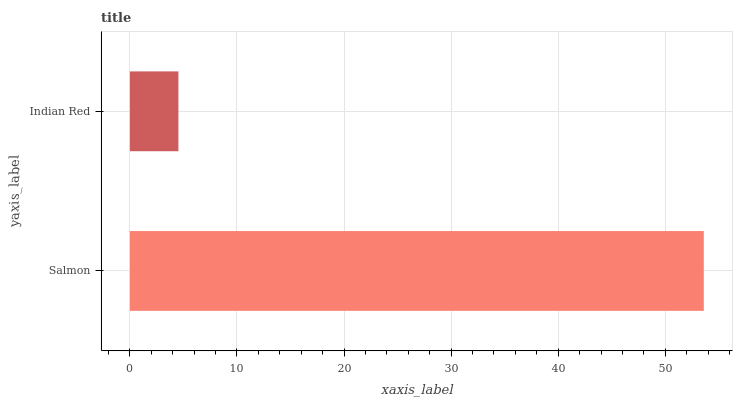Is Indian Red the minimum?
Answer yes or no. Yes. Is Salmon the maximum?
Answer yes or no. Yes. Is Indian Red the maximum?
Answer yes or no. No. Is Salmon greater than Indian Red?
Answer yes or no. Yes. Is Indian Red less than Salmon?
Answer yes or no. Yes. Is Indian Red greater than Salmon?
Answer yes or no. No. Is Salmon less than Indian Red?
Answer yes or no. No. Is Salmon the high median?
Answer yes or no. Yes. Is Indian Red the low median?
Answer yes or no. Yes. Is Indian Red the high median?
Answer yes or no. No. Is Salmon the low median?
Answer yes or no. No. 